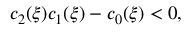<formula> <loc_0><loc_0><loc_500><loc_500>c _ { 2 } ( \xi ) c _ { 1 } ( \xi ) - c _ { 0 } ( \xi ) < 0 ,</formula> 